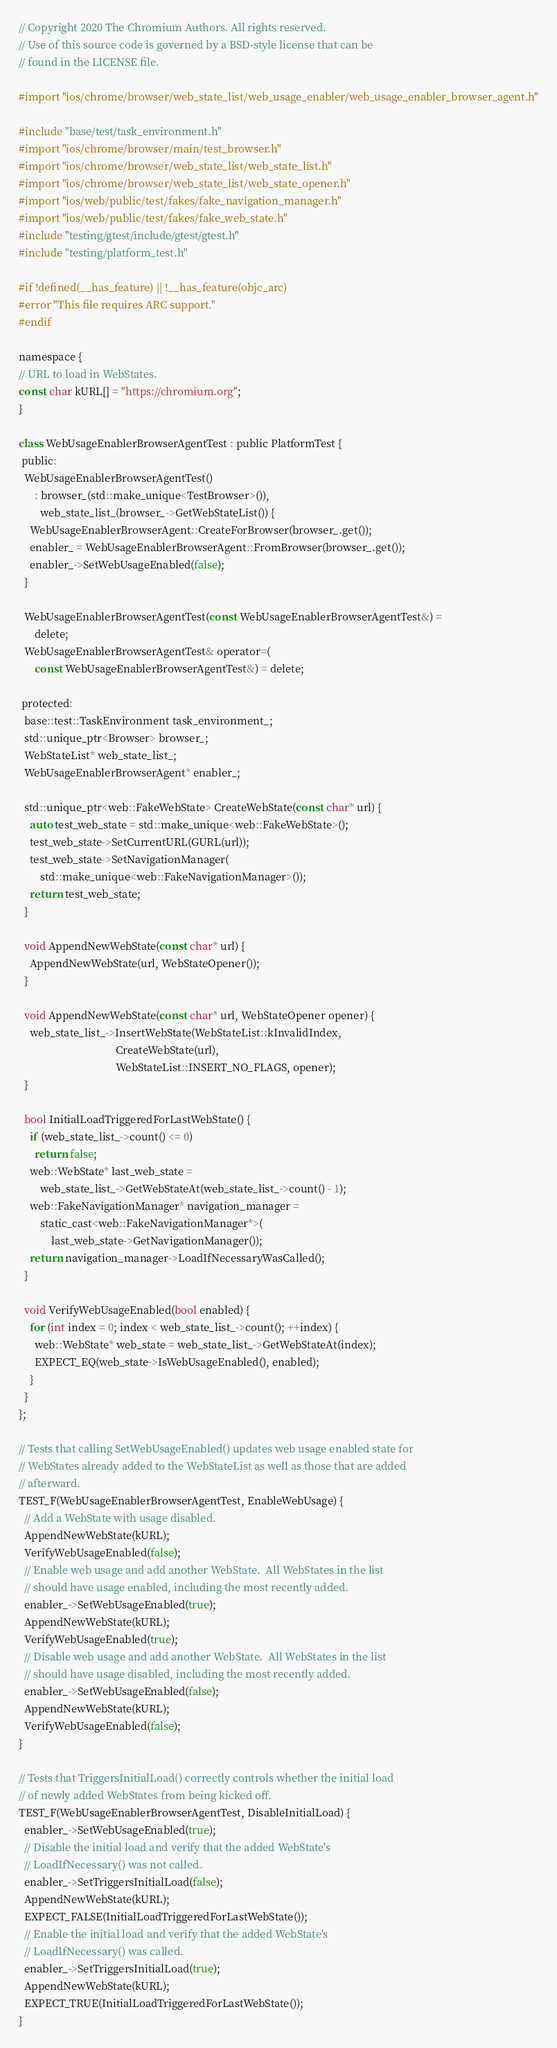<code> <loc_0><loc_0><loc_500><loc_500><_ObjectiveC_>// Copyright 2020 The Chromium Authors. All rights reserved.
// Use of this source code is governed by a BSD-style license that can be
// found in the LICENSE file.

#import "ios/chrome/browser/web_state_list/web_usage_enabler/web_usage_enabler_browser_agent.h"

#include "base/test/task_environment.h"
#import "ios/chrome/browser/main/test_browser.h"
#import "ios/chrome/browser/web_state_list/web_state_list.h"
#import "ios/chrome/browser/web_state_list/web_state_opener.h"
#import "ios/web/public/test/fakes/fake_navigation_manager.h"
#import "ios/web/public/test/fakes/fake_web_state.h"
#include "testing/gtest/include/gtest/gtest.h"
#include "testing/platform_test.h"

#if !defined(__has_feature) || !__has_feature(objc_arc)
#error "This file requires ARC support."
#endif

namespace {
// URL to load in WebStates.
const char kURL[] = "https://chromium.org";
}

class WebUsageEnablerBrowserAgentTest : public PlatformTest {
 public:
  WebUsageEnablerBrowserAgentTest()
      : browser_(std::make_unique<TestBrowser>()),
        web_state_list_(browser_->GetWebStateList()) {
    WebUsageEnablerBrowserAgent::CreateForBrowser(browser_.get());
    enabler_ = WebUsageEnablerBrowserAgent::FromBrowser(browser_.get());
    enabler_->SetWebUsageEnabled(false);
  }

  WebUsageEnablerBrowserAgentTest(const WebUsageEnablerBrowserAgentTest&) =
      delete;
  WebUsageEnablerBrowserAgentTest& operator=(
      const WebUsageEnablerBrowserAgentTest&) = delete;

 protected:
  base::test::TaskEnvironment task_environment_;
  std::unique_ptr<Browser> browser_;
  WebStateList* web_state_list_;
  WebUsageEnablerBrowserAgent* enabler_;

  std::unique_ptr<web::FakeWebState> CreateWebState(const char* url) {
    auto test_web_state = std::make_unique<web::FakeWebState>();
    test_web_state->SetCurrentURL(GURL(url));
    test_web_state->SetNavigationManager(
        std::make_unique<web::FakeNavigationManager>());
    return test_web_state;
  }

  void AppendNewWebState(const char* url) {
    AppendNewWebState(url, WebStateOpener());
  }

  void AppendNewWebState(const char* url, WebStateOpener opener) {
    web_state_list_->InsertWebState(WebStateList::kInvalidIndex,
                                    CreateWebState(url),
                                    WebStateList::INSERT_NO_FLAGS, opener);
  }

  bool InitialLoadTriggeredForLastWebState() {
    if (web_state_list_->count() <= 0)
      return false;
    web::WebState* last_web_state =
        web_state_list_->GetWebStateAt(web_state_list_->count() - 1);
    web::FakeNavigationManager* navigation_manager =
        static_cast<web::FakeNavigationManager*>(
            last_web_state->GetNavigationManager());
    return navigation_manager->LoadIfNecessaryWasCalled();
  }

  void VerifyWebUsageEnabled(bool enabled) {
    for (int index = 0; index < web_state_list_->count(); ++index) {
      web::WebState* web_state = web_state_list_->GetWebStateAt(index);
      EXPECT_EQ(web_state->IsWebUsageEnabled(), enabled);
    }
  }
};

// Tests that calling SetWebUsageEnabled() updates web usage enabled state for
// WebStates already added to the WebStateList as well as those that are added
// afterward.
TEST_F(WebUsageEnablerBrowserAgentTest, EnableWebUsage) {
  // Add a WebState with usage disabled.
  AppendNewWebState(kURL);
  VerifyWebUsageEnabled(false);
  // Enable web usage and add another WebState.  All WebStates in the list
  // should have usage enabled, including the most recently added.
  enabler_->SetWebUsageEnabled(true);
  AppendNewWebState(kURL);
  VerifyWebUsageEnabled(true);
  // Disable web usage and add another WebState.  All WebStates in the list
  // should have usage disabled, including the most recently added.
  enabler_->SetWebUsageEnabled(false);
  AppendNewWebState(kURL);
  VerifyWebUsageEnabled(false);
}

// Tests that TriggersInitialLoad() correctly controls whether the initial load
// of newly added WebStates from being kicked off.
TEST_F(WebUsageEnablerBrowserAgentTest, DisableInitialLoad) {
  enabler_->SetWebUsageEnabled(true);
  // Disable the initial load and verify that the added WebState's
  // LoadIfNecessary() was not called.
  enabler_->SetTriggersInitialLoad(false);
  AppendNewWebState(kURL);
  EXPECT_FALSE(InitialLoadTriggeredForLastWebState());
  // Enable the initial load and verify that the added WebState's
  // LoadIfNecessary() was called.
  enabler_->SetTriggersInitialLoad(true);
  AppendNewWebState(kURL);
  EXPECT_TRUE(InitialLoadTriggeredForLastWebState());
}
</code> 